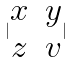<formula> <loc_0><loc_0><loc_500><loc_500>| \begin{matrix} x & y \\ z & v \end{matrix} |</formula> 